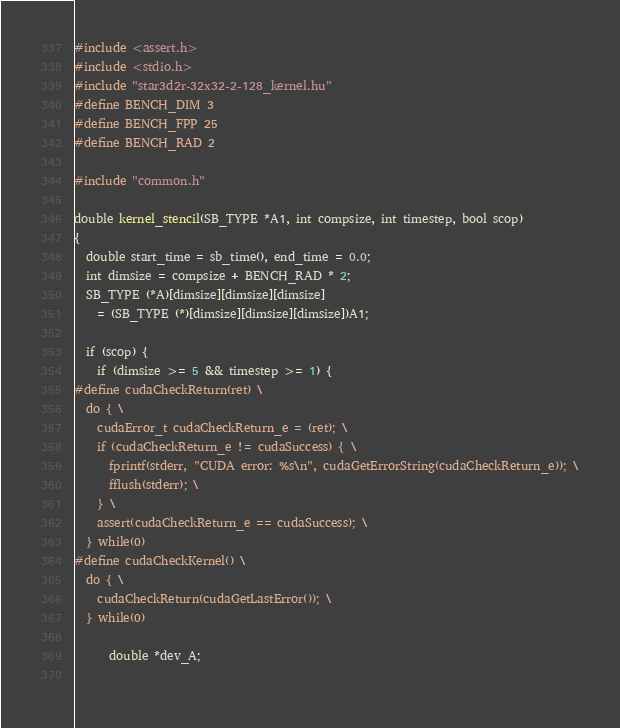Convert code to text. <code><loc_0><loc_0><loc_500><loc_500><_Cuda_>#include <assert.h>
#include <stdio.h>
#include "star3d2r-32x32-2-128_kernel.hu"
#define BENCH_DIM 3
#define BENCH_FPP 25
#define BENCH_RAD 2

#include "common.h"

double kernel_stencil(SB_TYPE *A1, int compsize, int timestep, bool scop)
{
  double start_time = sb_time(), end_time = 0.0;
  int dimsize = compsize + BENCH_RAD * 2;
  SB_TYPE (*A)[dimsize][dimsize][dimsize]
    = (SB_TYPE (*)[dimsize][dimsize][dimsize])A1;

  if (scop) {
    if (dimsize >= 5 && timestep >= 1) {
#define cudaCheckReturn(ret) \
  do { \
    cudaError_t cudaCheckReturn_e = (ret); \
    if (cudaCheckReturn_e != cudaSuccess) { \
      fprintf(stderr, "CUDA error: %s\n", cudaGetErrorString(cudaCheckReturn_e)); \
      fflush(stderr); \
    } \
    assert(cudaCheckReturn_e == cudaSuccess); \
  } while(0)
#define cudaCheckKernel() \
  do { \
    cudaCheckReturn(cudaGetLastError()); \
  } while(0)

      double *dev_A;
      </code> 